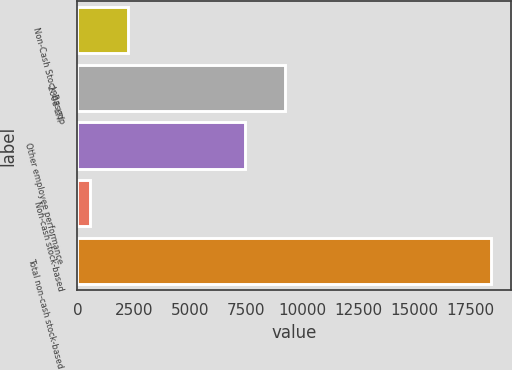Convert chart to OTSL. <chart><loc_0><loc_0><loc_500><loc_500><bar_chart><fcel>Non-Cash Stock-Based<fcel>2008 LTIP<fcel>Other employee performance<fcel>Non-cash stock-based<fcel>Total non-cash stock-based<nl><fcel>2237.7<fcel>9246<fcel>7471<fcel>566<fcel>18388.7<nl></chart> 